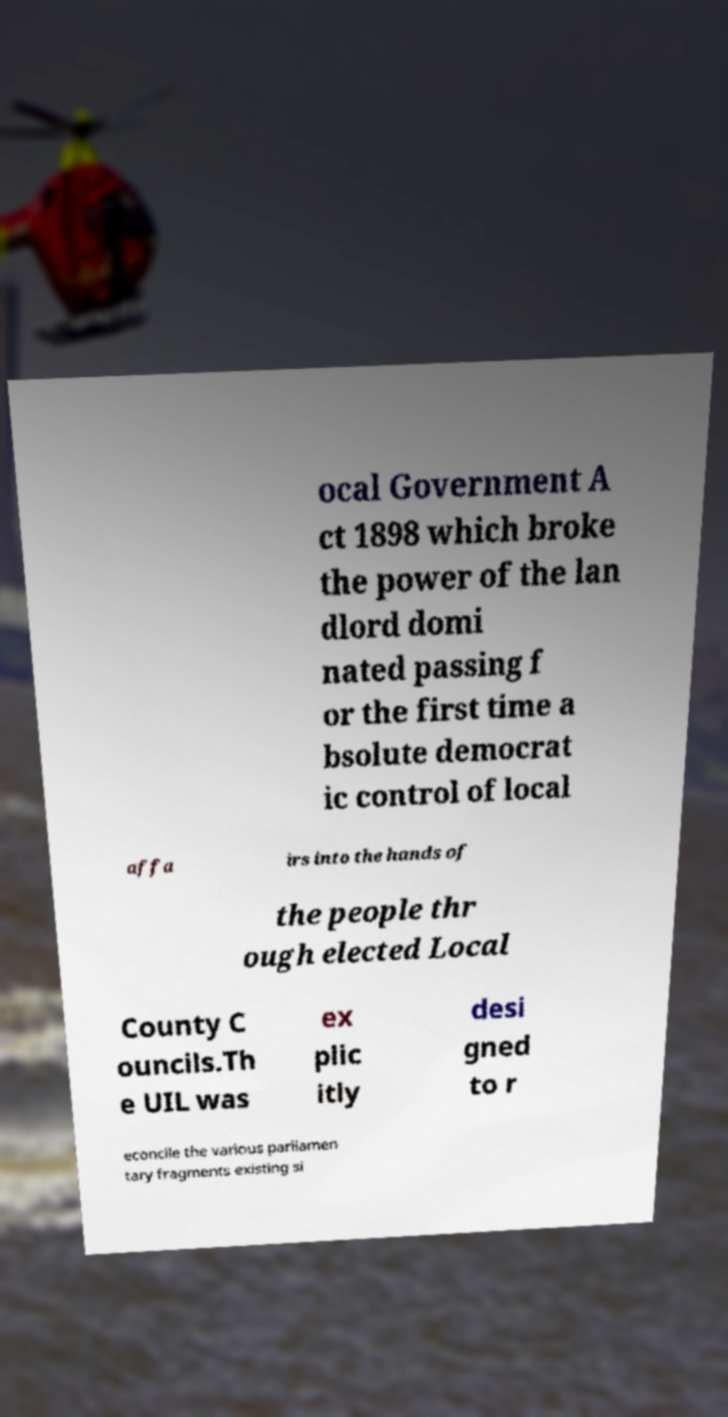Please identify and transcribe the text found in this image. ocal Government A ct 1898 which broke the power of the lan dlord domi nated passing f or the first time a bsolute democrat ic control of local affa irs into the hands of the people thr ough elected Local County C ouncils.Th e UIL was ex plic itly desi gned to r econcile the various parliamen tary fragments existing si 